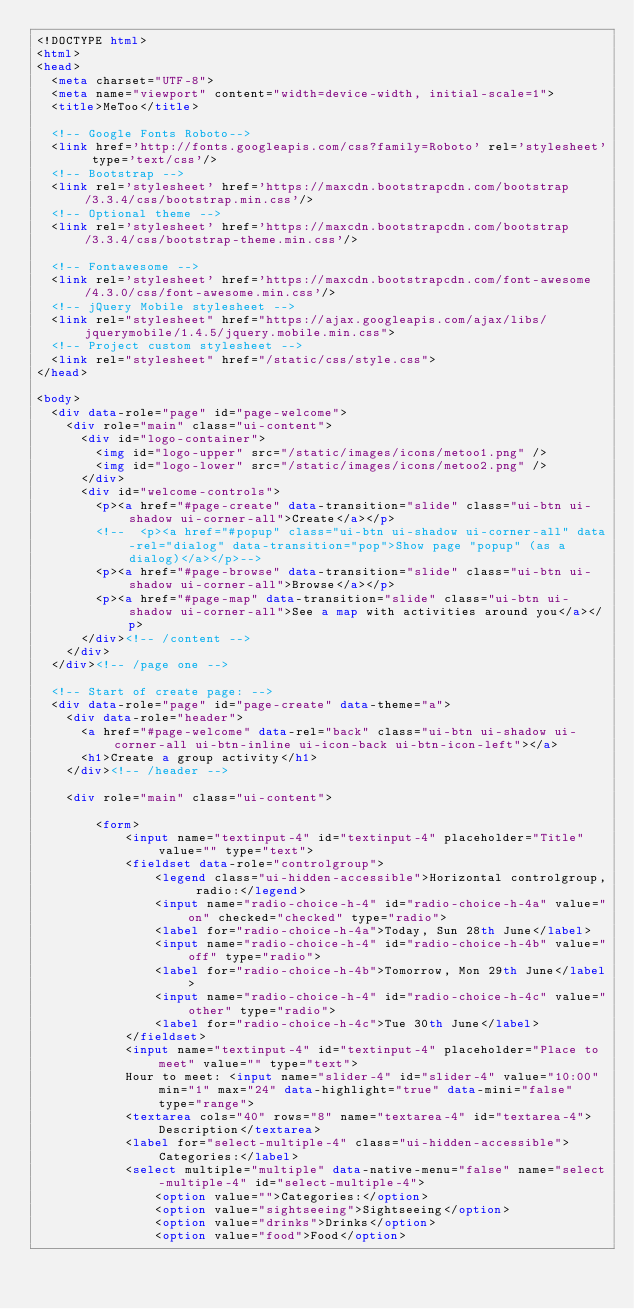Convert code to text. <code><loc_0><loc_0><loc_500><loc_500><_HTML_><!DOCTYPE html>
<html>
<head>
  <meta charset="UTF-8">
  <meta name="viewport" content="width=device-width, initial-scale=1">
  <title>MeToo</title>

  <!-- Google Fonts Roboto-->
  <link href='http://fonts.googleapis.com/css?family=Roboto' rel='stylesheet' type='text/css'/>
  <!-- Bootstrap -->
  <link rel='stylesheet' href='https://maxcdn.bootstrapcdn.com/bootstrap/3.3.4/css/bootstrap.min.css'/>
  <!-- Optional theme -->
  <link rel='stylesheet' href='https://maxcdn.bootstrapcdn.com/bootstrap/3.3.4/css/bootstrap-theme.min.css'/>

  <!-- Fontawesome -->
  <link rel='stylesheet' href='https://maxcdn.bootstrapcdn.com/font-awesome/4.3.0/css/font-awesome.min.css'/>
  <!-- jQuery Mobile stylesheet -->
  <link rel="stylesheet" href="https://ajax.googleapis.com/ajax/libs/jquerymobile/1.4.5/jquery.mobile.min.css">
  <!-- Project custom stylesheet -->
  <link rel="stylesheet" href="/static/css/style.css">
</head>

<body>
  <div data-role="page" id="page-welcome">
    <div role="main" class="ui-content">
      <div id="logo-container">
        <img id="logo-upper" src="/static/images/icons/metoo1.png" />
        <img id="logo-lower" src="/static/images/icons/metoo2.png" />
      </div>
      <div id="welcome-controls">
        <p><a href="#page-create" data-transition="slide" class="ui-btn ui-shadow ui-corner-all">Create</a></p>
        <!--	<p><a href="#popup" class="ui-btn ui-shadow ui-corner-all" data-rel="dialog" data-transition="pop">Show page "popup" (as a dialog)</a></p>-->
        <p><a href="#page-browse" data-transition="slide" class="ui-btn ui-shadow ui-corner-all">Browse</a></p>
        <p><a href="#page-map" data-transition="slide" class="ui-btn ui-shadow ui-corner-all">See a map with activities around you</a></p>
      </div><!-- /content -->
    </div>
  </div><!-- /page one -->

  <!-- Start of create page: -->
  <div data-role="page" id="page-create" data-theme="a">
    <div data-role="header">
      <a href="#page-welcome" data-rel="back" class="ui-btn ui-shadow ui-corner-all ui-btn-inline ui-icon-back ui-btn-icon-left"></a>
      <h1>Create a group activity</h1>
    </div><!-- /header -->

    <div role="main" class="ui-content">

        <form>
            <input name="textinput-4" id="textinput-4" placeholder="Title" value="" type="text">
            <fieldset data-role="controlgroup">
                <legend class="ui-hidden-accessible">Horizontal controlgroup, radio:</legend>
                <input name="radio-choice-h-4" id="radio-choice-h-4a" value="on" checked="checked" type="radio">
                <label for="radio-choice-h-4a">Today, Sun 28th June</label>
                <input name="radio-choice-h-4" id="radio-choice-h-4b" value="off" type="radio">
                <label for="radio-choice-h-4b">Tomorrow, Mon 29th June</label>
                <input name="radio-choice-h-4" id="radio-choice-h-4c" value="other" type="radio">
                <label for="radio-choice-h-4c">Tue 30th June</label>
            </fieldset>
            <input name="textinput-4" id="textinput-4" placeholder="Place to meet" value="" type="text">
            Hour to meet: <input name="slider-4" id="slider-4" value="10:00" min="1" max="24" data-highlight="true" data-mini="false" type="range">
            <textarea cols="40" rows="8" name="textarea-4" id="textarea-4">Description</textarea>
            <label for="select-multiple-4" class="ui-hidden-accessible">Categories:</label>
            <select multiple="multiple" data-native-menu="false" name="select-multiple-4" id="select-multiple-4">
                <option value="">Categories:</option>
                <option value="sightseeing">Sightseeing</option>
                <option value="drinks">Drinks</option>
                <option value="food">Food</option></code> 